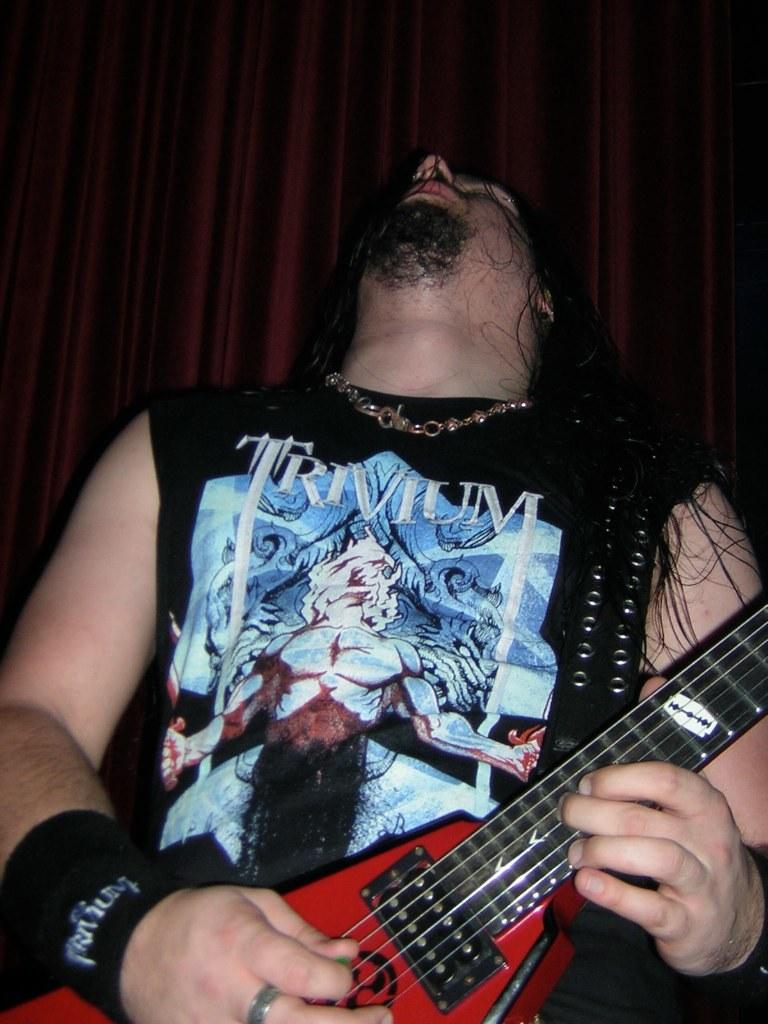What is the man in the image doing? The man in the image is playing the guitar. What is the man wearing on his upper body? The man is wearing a T-shirt. What accessory is the man wearing in the image? The man is wearing a necklace. What facial hair does the man have? The man has a beard. What type of hairstyle does the man have? The man has long hair. What suggestion does the man's mother give him in the image? There is no mention of the man's mother or any suggestions in the image. 